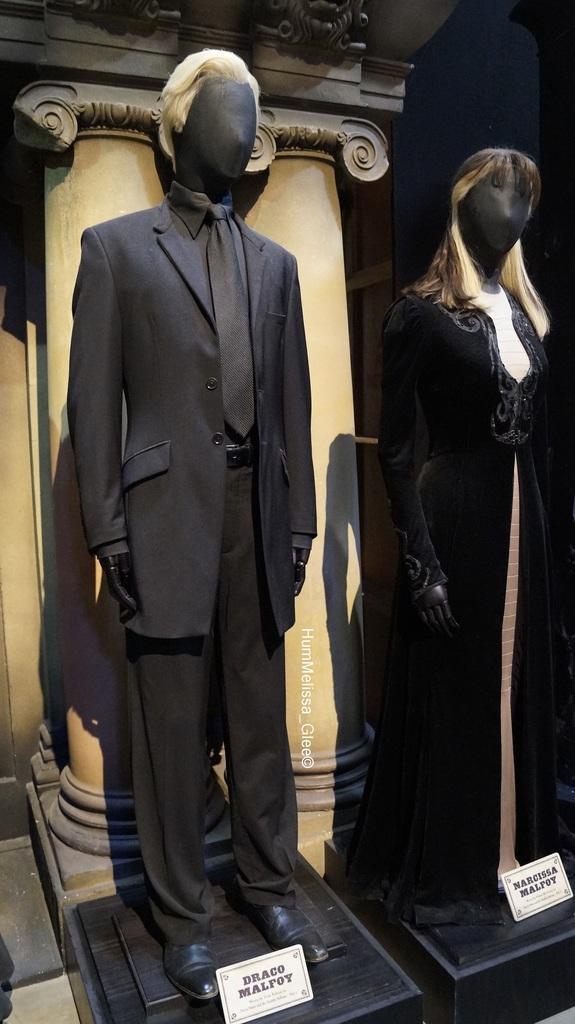Describe this image in one or two sentences. In this picture there are two statues wearing black clothes and there are some other objects in the background. 